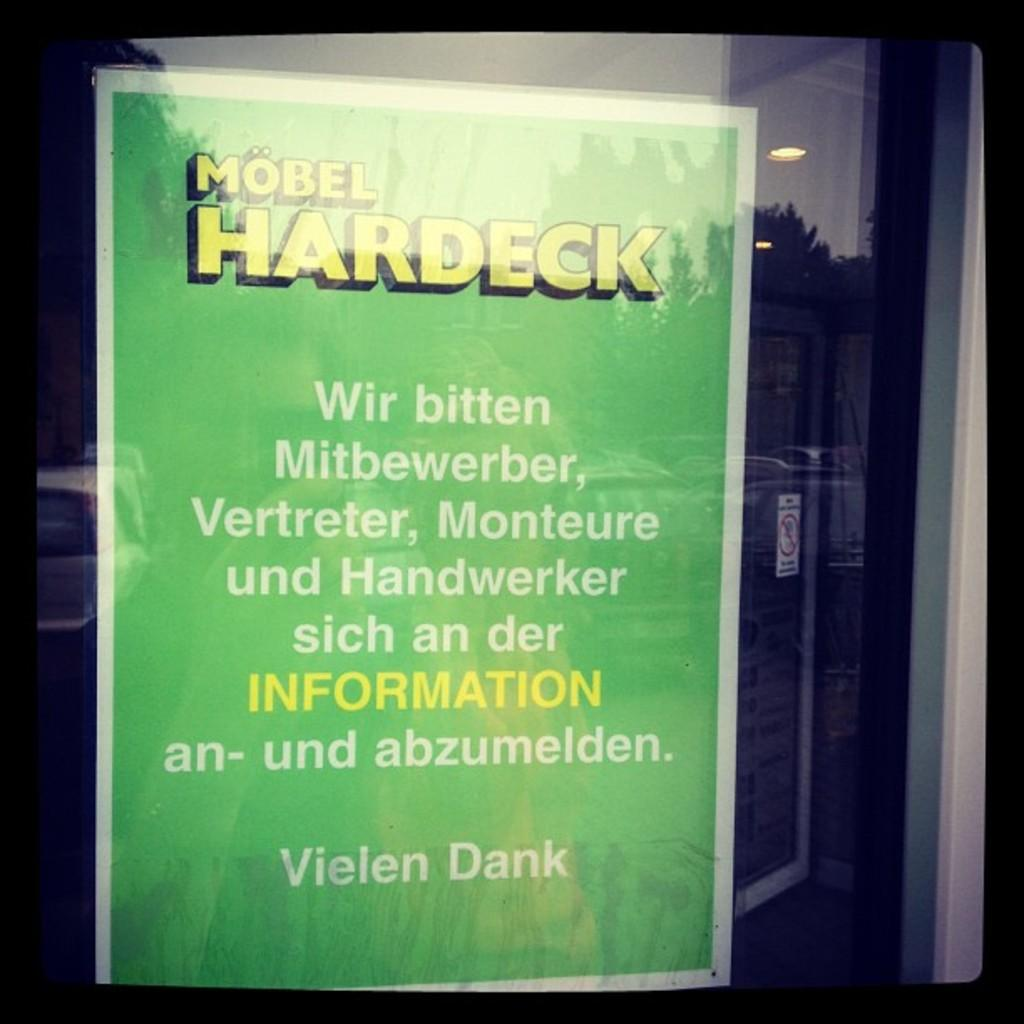Provide a one-sentence caption for the provided image. A sign in German hangs in a window for Mobel Hardeck. 